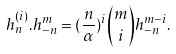<formula> <loc_0><loc_0><loc_500><loc_500>h _ { n } ^ { ( i ) } . h _ { - n } ^ { m } = ( \frac { n } { \alpha } ) ^ { i } \binom { m } { i } h _ { - n } ^ { m - i } .</formula> 